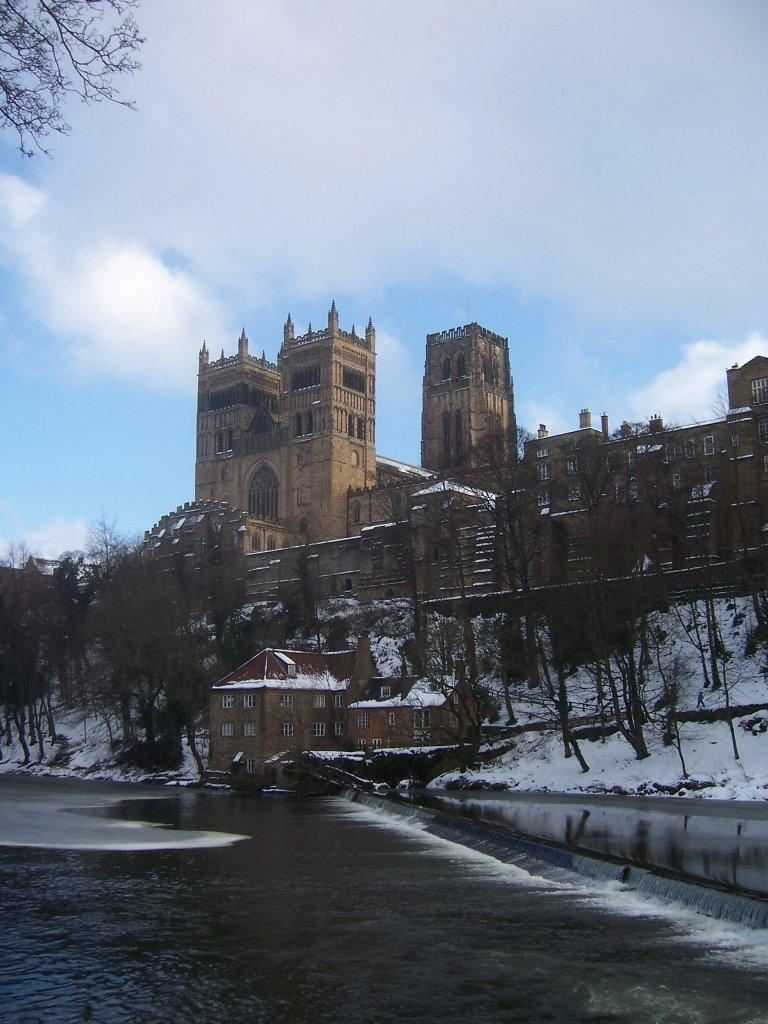What type of structures can be seen in the image? There are buildings in the image. What other natural elements are present in the image? There are trees in the image. What is the condition of the ground in the image? There is snow on the ground in the image. What is visible in the sky in the image? The sky is visible in the image, and it has clouds. What type of water is visible in the image? There is water visible in the image. How many eyes can be seen on the desk in the image? There is no desk or eyes present in the image. What type of pie is being served in the image? There is no pie present in the image. 